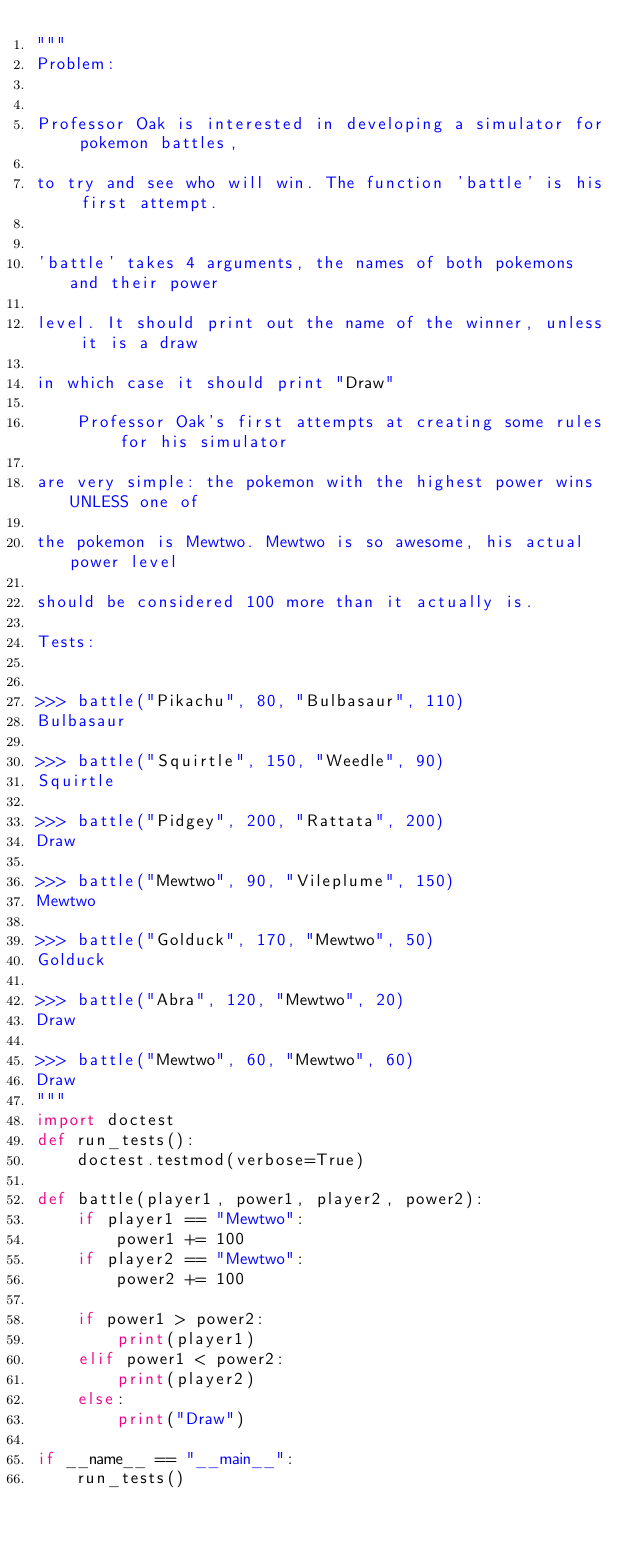Convert code to text. <code><loc_0><loc_0><loc_500><loc_500><_Python_>"""
Problem:

    
Professor Oak is interested in developing a simulator for pokemon battles,
    
to try and see who will win. The function 'battle' is his first attempt.

    
'battle' takes 4 arguments, the names of both pokemons and their power
    
level. It should print out the name of the winner, unless it is a draw
    
in which case it should print "Draw"

    Professor Oak's first attempts at creating some rules for his simulator
    
are very simple: the pokemon with the highest power wins UNLESS one of
    
the pokemon is Mewtwo. Mewtwo is so awesome, his actual power level
    
should be considered 100 more than it actually is.

Tests:

    
>>> battle("Pikachu", 80, "Bulbasaur", 110)
Bulbasaur
    
>>> battle("Squirtle", 150, "Weedle", 90)
Squirtle
    
>>> battle("Pidgey", 200, "Rattata", 200)
Draw
    
>>> battle("Mewtwo", 90, "Vileplume", 150)
Mewtwo
    
>>> battle("Golduck", 170, "Mewtwo", 50)
Golduck
    
>>> battle("Abra", 120, "Mewtwo", 20)
Draw
    
>>> battle("Mewtwo", 60, "Mewtwo", 60)
Draw
"""
import doctest
def run_tests():
    doctest.testmod(verbose=True)

def battle(player1, power1, player2, power2):
    if player1 == "Mewtwo":
        power1 += 100
    if player2 == "Mewtwo":
        power2 += 100
    
    if power1 > power2:
        print(player1)
    elif power1 < power2:
        print(player2)
    else:
        print("Draw")

if __name__ == "__main__":
    run_tests()</code> 